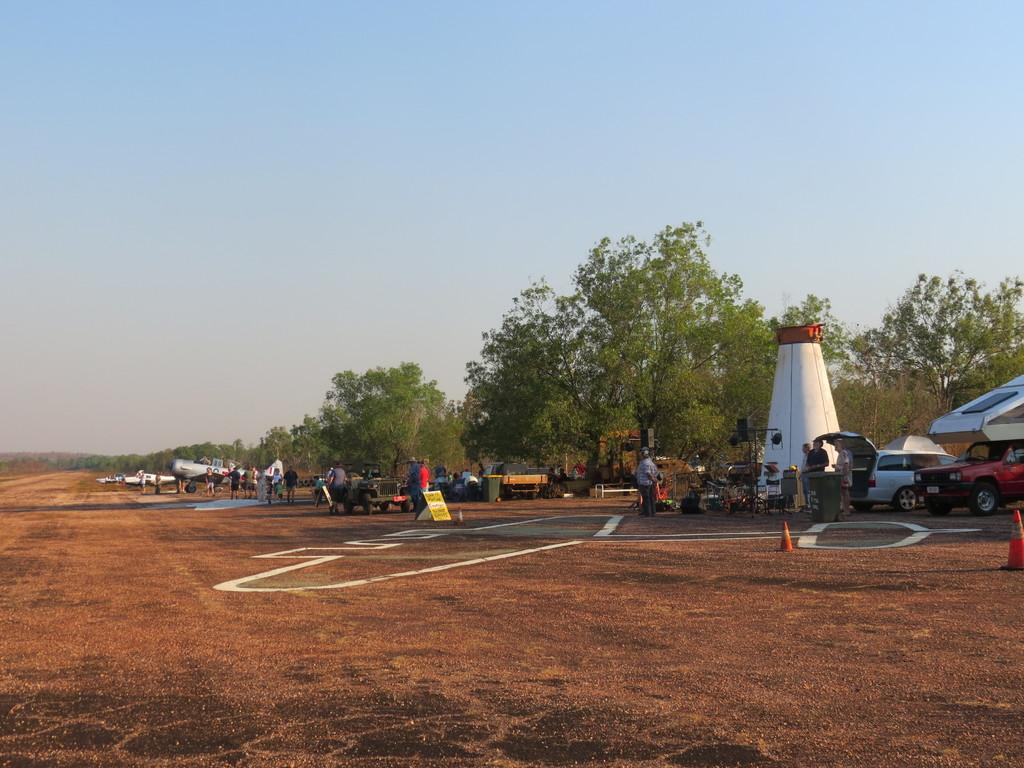What is located in the middle of the image? There are planes, vehicles, and people in the middle of the image. What type of transportation is present in the image? Planes and vehicles are present in the image. What are the people in the image doing? The people are standing and sitting in the middle of the image. What can be seen behind the planes, vehicles, and people? There are trees visible behind them. What is visible at the top of the image? The sky is visible at the top of the image. Can you tell me how many yaks are grazing behind the trees in the image? There are no yaks present in the image; only trees are visible behind the planes, vehicles, and people. What type of door can be seen on the planes in the image? There are no doors visible on the planes in the image; only the exterior of the planes is shown. 